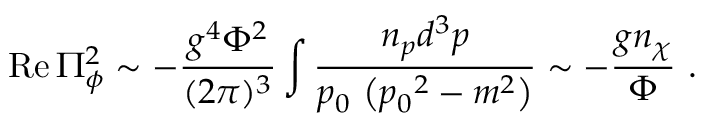Convert formula to latex. <formula><loc_0><loc_0><loc_500><loc_500>R e \, \Pi _ { \phi } ^ { 2 } \sim - { \frac { g ^ { 4 } \Phi ^ { 2 } } { ( 2 \pi ) ^ { 3 } } } \int { \frac { n _ { p } d ^ { 3 } p } { p _ { 0 } \left ( { p _ { 0 } } ^ { 2 } - m ^ { 2 } \right ) } } \sim - { \frac { g n _ { \chi } } { \Phi } } \ .</formula> 